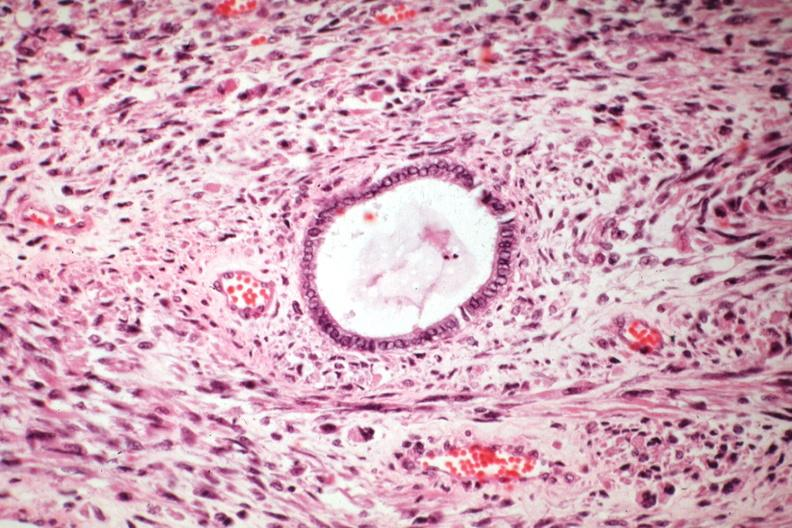what is present?
Answer the question using a single word or phrase. Uterus 